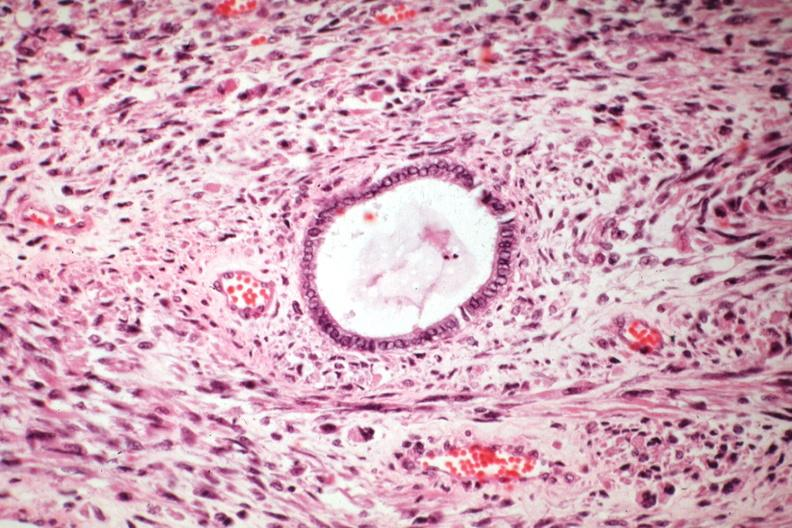what is present?
Answer the question using a single word or phrase. Uterus 